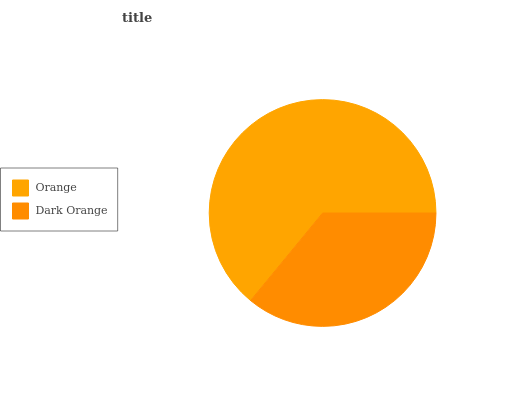Is Dark Orange the minimum?
Answer yes or no. Yes. Is Orange the maximum?
Answer yes or no. Yes. Is Dark Orange the maximum?
Answer yes or no. No. Is Orange greater than Dark Orange?
Answer yes or no. Yes. Is Dark Orange less than Orange?
Answer yes or no. Yes. Is Dark Orange greater than Orange?
Answer yes or no. No. Is Orange less than Dark Orange?
Answer yes or no. No. Is Orange the high median?
Answer yes or no. Yes. Is Dark Orange the low median?
Answer yes or no. Yes. Is Dark Orange the high median?
Answer yes or no. No. Is Orange the low median?
Answer yes or no. No. 